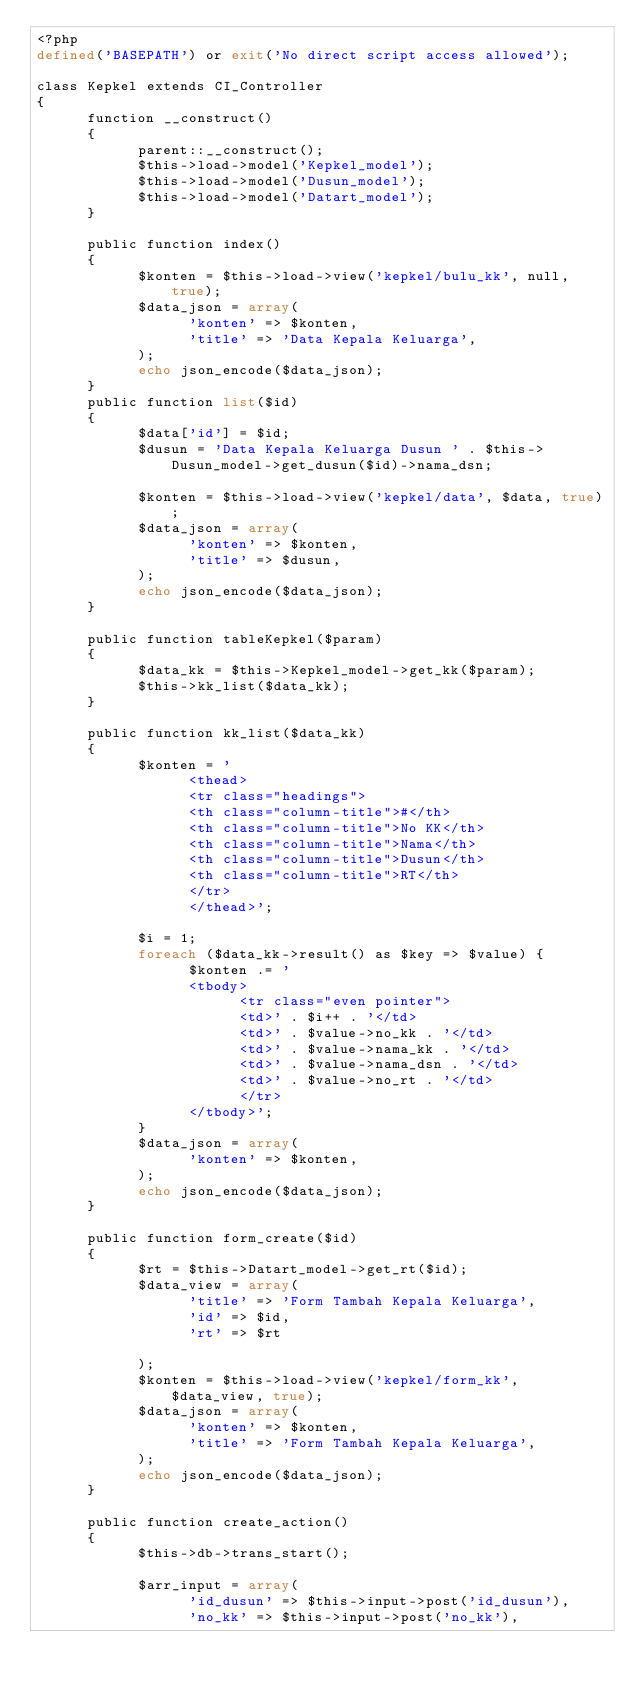<code> <loc_0><loc_0><loc_500><loc_500><_PHP_><?php
defined('BASEPATH') or exit('No direct script access allowed');

class Kepkel extends CI_Controller
{
      function __construct()
      {
            parent::__construct();
            $this->load->model('Kepkel_model');
            $this->load->model('Dusun_model');
            $this->load->model('Datart_model');
      }

      public function index()
      {
            $konten = $this->load->view('kepkel/bulu_kk', null, true);
            $data_json = array(
                  'konten' => $konten,
                  'title' => 'Data Kepala Keluarga',
            );
            echo json_encode($data_json);
      }
      public function list($id)
      {
            $data['id'] = $id;
            $dusun = 'Data Kepala Keluarga Dusun ' . $this->Dusun_model->get_dusun($id)->nama_dsn;

            $konten = $this->load->view('kepkel/data', $data, true);
            $data_json = array(
                  'konten' => $konten,
                  'title' => $dusun,
            );
            echo json_encode($data_json);
      }

      public function tableKepkel($param)
      {
            $data_kk = $this->Kepkel_model->get_kk($param);
            $this->kk_list($data_kk);
      }

      public function kk_list($data_kk)
      {
            $konten = '
                  <thead>
                  <tr class="headings">
                  <th class="column-title">#</th>
                  <th class="column-title">No KK</th>
                  <th class="column-title">Nama</th>
                  <th class="column-title">Dusun</th>
                  <th class="column-title">RT</th>
                  </tr>
                  </thead>';

            $i = 1;
            foreach ($data_kk->result() as $key => $value) {
                  $konten .= '
                  <tbody>
                        <tr class="even pointer">
                        <td>' . $i++ . '</td>
                        <td>' . $value->no_kk . '</td>
                        <td>' . $value->nama_kk . '</td>
                        <td>' . $value->nama_dsn . '</td>
                        <td>' . $value->no_rt . '</td>
                        </tr>
                  </tbody>';
            }
            $data_json = array(
                  'konten' => $konten,
            );
            echo json_encode($data_json);
      }

      public function form_create($id)
      {
            $rt = $this->Datart_model->get_rt($id);
            $data_view = array(
                  'title' => 'Form Tambah Kepala Keluarga',
                  'id' => $id,
                  'rt' => $rt

            );
            $konten = $this->load->view('kepkel/form_kk', $data_view, true);
            $data_json = array(
                  'konten' => $konten,
                  'title' => 'Form Tambah Kepala Keluarga',
            );
            echo json_encode($data_json);
      }

      public function create_action()
      {
            $this->db->trans_start();

            $arr_input = array(
                  'id_dusun' => $this->input->post('id_dusun'),
                  'no_kk' => $this->input->post('no_kk'),</code> 